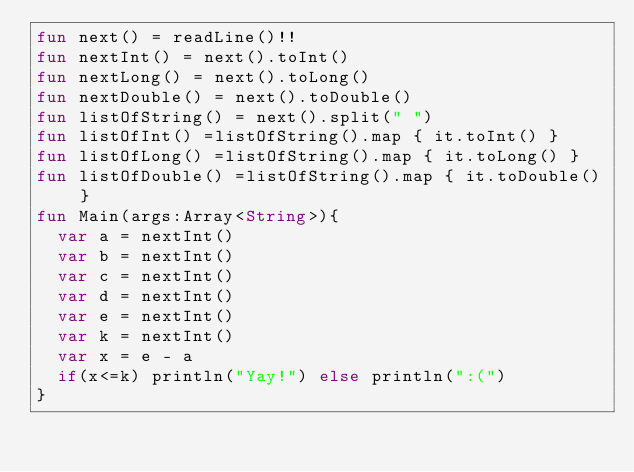Convert code to text. <code><loc_0><loc_0><loc_500><loc_500><_Kotlin_>fun next() = readLine()!!
fun nextInt() = next().toInt()
fun nextLong() = next().toLong()
fun nextDouble() = next().toDouble()
fun listOfString() = next().split(" ")
fun listOfInt() =listOfString().map { it.toInt() }
fun listOfLong() =listOfString().map { it.toLong() }
fun listOfDouble() =listOfString().map { it.toDouble() }
fun Main(args:Array<String>){
  var a = nextInt()
  var b = nextInt()
  var c = nextInt()
  var d = nextInt()
  var e = nextInt()
  var k = nextInt()
  var x = e - a
  if(x<=k) println("Yay!") else println(":(")
}
</code> 